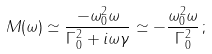<formula> <loc_0><loc_0><loc_500><loc_500>M ( \omega ) \simeq \frac { - \omega _ { 0 } ^ { 2 } \omega } { \Gamma _ { 0 } ^ { 2 } + i \omega \gamma } \simeq - \frac { \omega _ { 0 } ^ { 2 } \omega } { \Gamma _ { 0 } ^ { 2 } } \, ;</formula> 